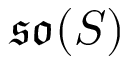<formula> <loc_0><loc_0><loc_500><loc_500>{ \mathfrak { s o } } ( S )</formula> 